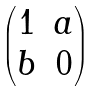<formula> <loc_0><loc_0><loc_500><loc_500>\begin{pmatrix} 1 & a \\ b & 0 \end{pmatrix}</formula> 